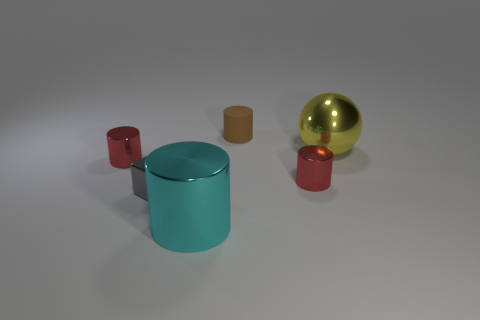Add 3 big metal cylinders. How many objects exist? 9 Subtract all cubes. How many objects are left? 5 Add 3 gray shiny blocks. How many gray shiny blocks exist? 4 Subtract 1 gray blocks. How many objects are left? 5 Subtract all big objects. Subtract all cyan shiny cylinders. How many objects are left? 3 Add 3 yellow things. How many yellow things are left? 4 